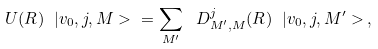Convert formula to latex. <formula><loc_0><loc_0><loc_500><loc_500>U ( R ) \ | v _ { 0 } , j , M > \ = \sum _ { M ^ { \prime } } \ D ^ { j } _ { M ^ { \prime } , M } ( R ) \ | v _ { 0 } , j , M ^ { \prime } > \, ,</formula> 